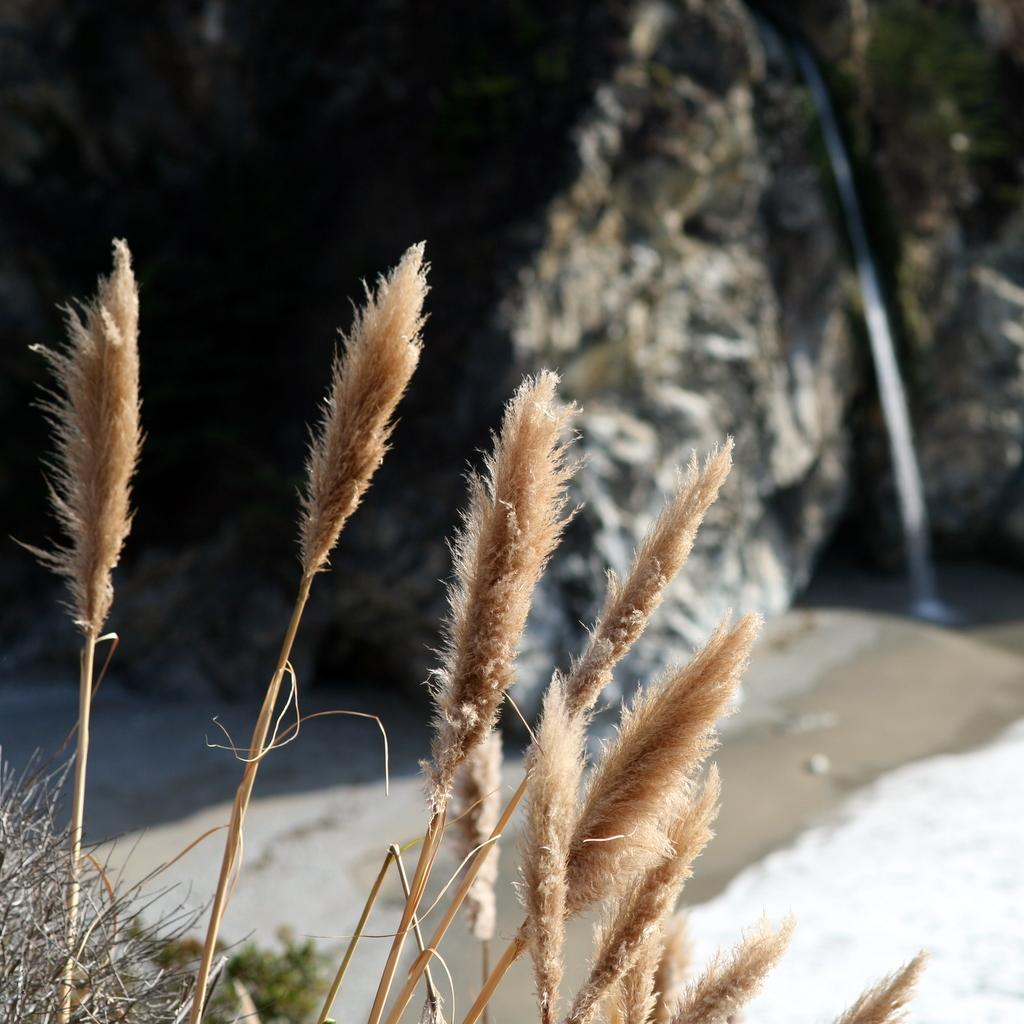Where was the image taken? The image was taken outside. What can be seen in the foreground of the image? There are plants in the foreground of the image. What type of objects can be seen in the background of the image? There are objects in the background of the image that resemble rocks. What is the price of the soap in the image? There is no soap present in the image, so it is not possible to determine its price. 